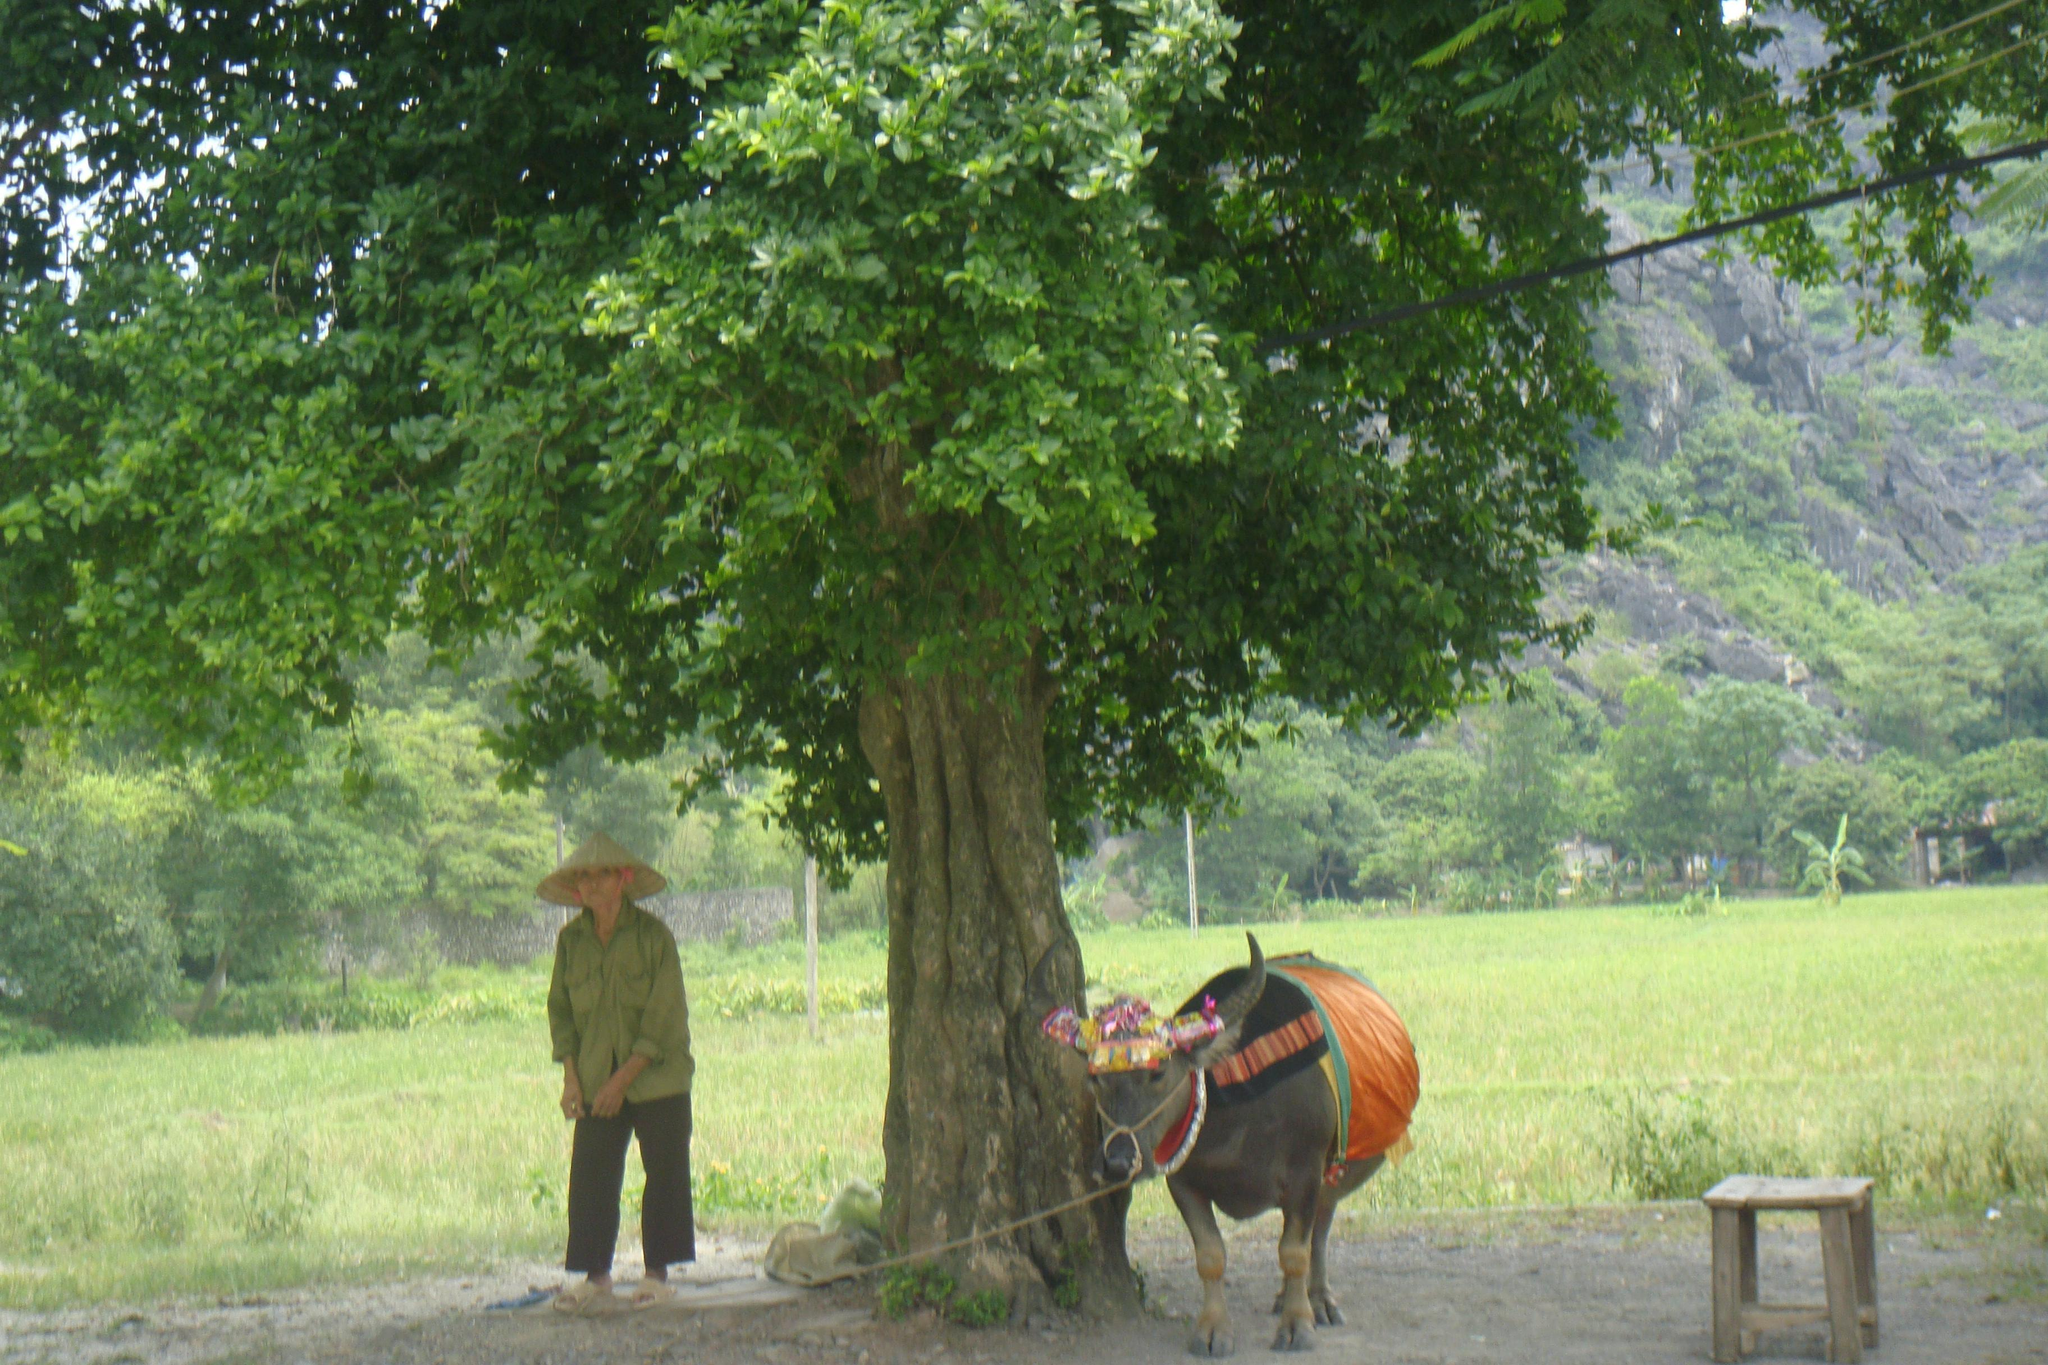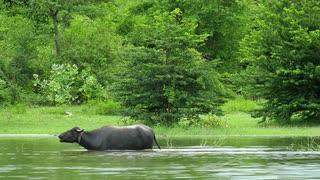The first image is the image on the left, the second image is the image on the right. Given the left and right images, does the statement "The left and right image contains the same number black bulls." hold true? Answer yes or no. Yes. The first image is the image on the left, the second image is the image on the right. For the images shown, is this caption "The right image features at least one leftward-headed water buffalo standing in profile in water that reaches its belly." true? Answer yes or no. Yes. 